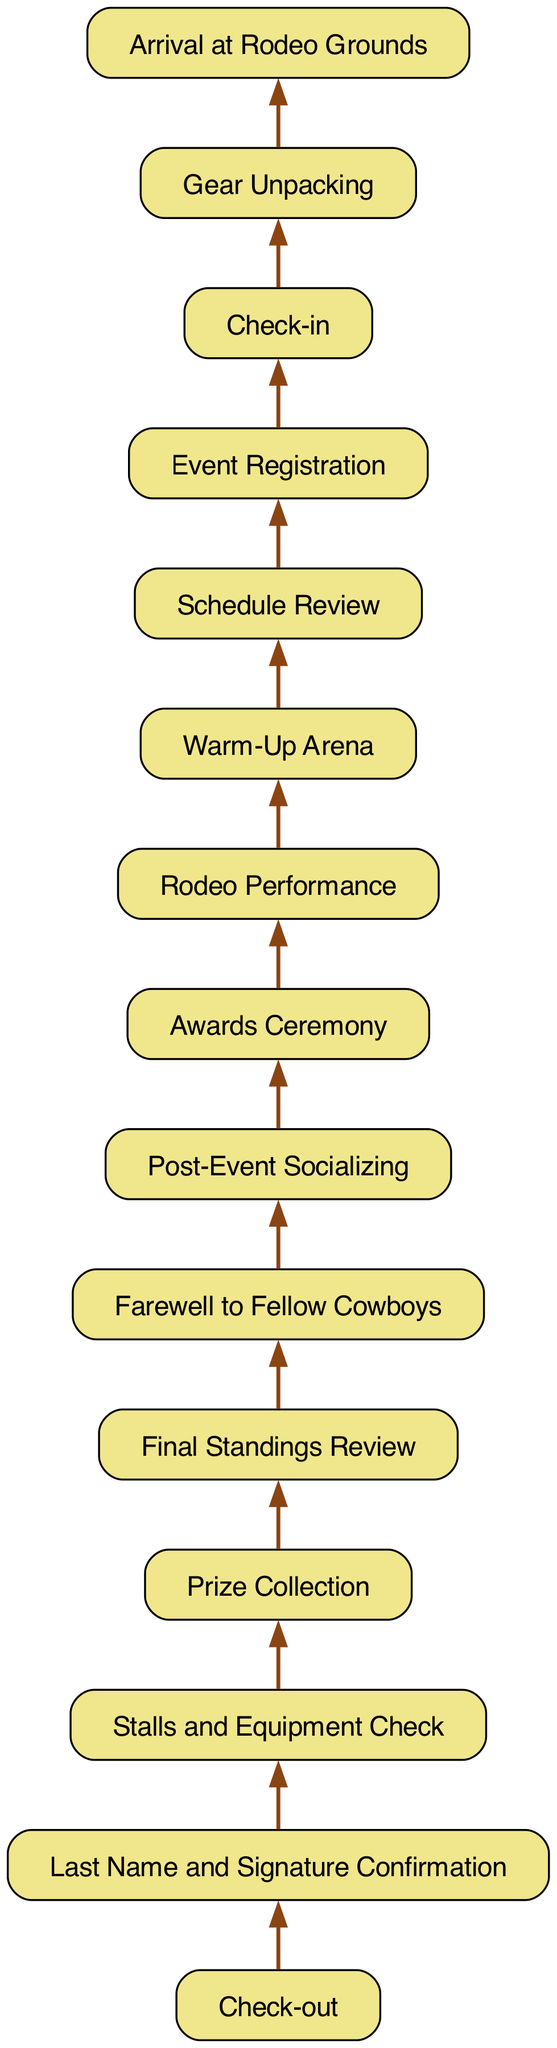What is the first step when arriving at the rodeo event? The diagram indicates that the first step upon arriving at the rodeo grounds is "Arrival at Rodeo Grounds". This is the initial action that kicks off the sequence of activities in the event.
Answer: Arrival at Rodeo Grounds How many nodes are in the flowchart? To determine the number of nodes, we can count each unique step listed in the flowchart. The provided data indicates a total of 12 distinct nodes leading from check-in to check-out.
Answer: 12 What is the final step in the process? The flowchart shows that the final step before check-out is "Last Name and Signature Confirmation". This is the concluding action that participants must complete.
Answer: Last Name and Signature Confirmation Which step comes directly after "Warm-Up Arena"? The diagram states that after "Warm-Up Arena", the participant should proceed to "Rodeo Performance". This illustrates the logical flow from preparation to the main event.
Answer: Rodeo Performance What is the relationship between "Check-in" and "Gear Unpacking"? The flowchart indicates a direct sequence where "Check-in" leads to "Gear Unpacking", meaning gear unpacking is contingent on successful check-in. This reflects the chronological order of tasks.
Answer: Gear Unpacking What is the second to last step in the flow? By tracking the diagram from the end, the second to last step before final check-out is "Prize Collection". This step occurs right before confirming signatures and last names.
Answer: Prize Collection Which activities come after "Awards Ceremony"? According to the flowchart, the activity that follows "Awards Ceremony" is "Post-Event Socializing". This indicates a networking opportunity after formal recognition.
Answer: Post-Event Socializing What is one of the prerequisites for “Final Standings Review”? The diagram shows that to reach "Final Standings Review", you must first participate in "Prize Collection". This order signifies the completion of prize distribution before reviewing standings.
Answer: Prize Collection What step occurs before "Schedule Review"? The flow indicates that "Warm-Up Arena" is the step that occurs immediately before "Schedule Review", suggesting that participants should warm up before checking the event schedule.
Answer: Warm-Up Arena 